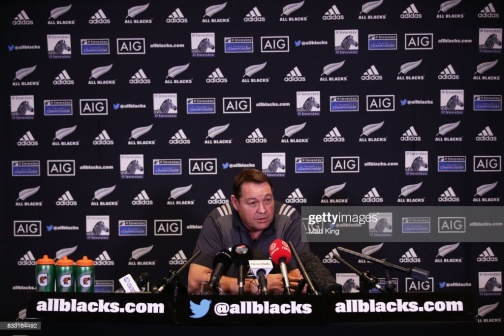What do you think is going on in this snapshot? This image appears to capture a moment during a press conference. The focus is on a man seated at a desk, surrounded by microphones and looking intently, likely responding to questions or delivering statements. He wears a blue shirt which stands out against the backdrop filled with 'allblacks.com' and 'AIG' logos, suggesting the event is associated with the All Blacks, New Zealand's national rugby team, supported by their sponsor AIG. The array of water bottles in front of him is typical for such events, suggesting a prolonged session of speaking and the need for hydration. The structured layout of the backdrop and the formal setting imply this is a professional and possibly widely broadcasted interaction, emphasizing the importance of the subject matter being discussed. 